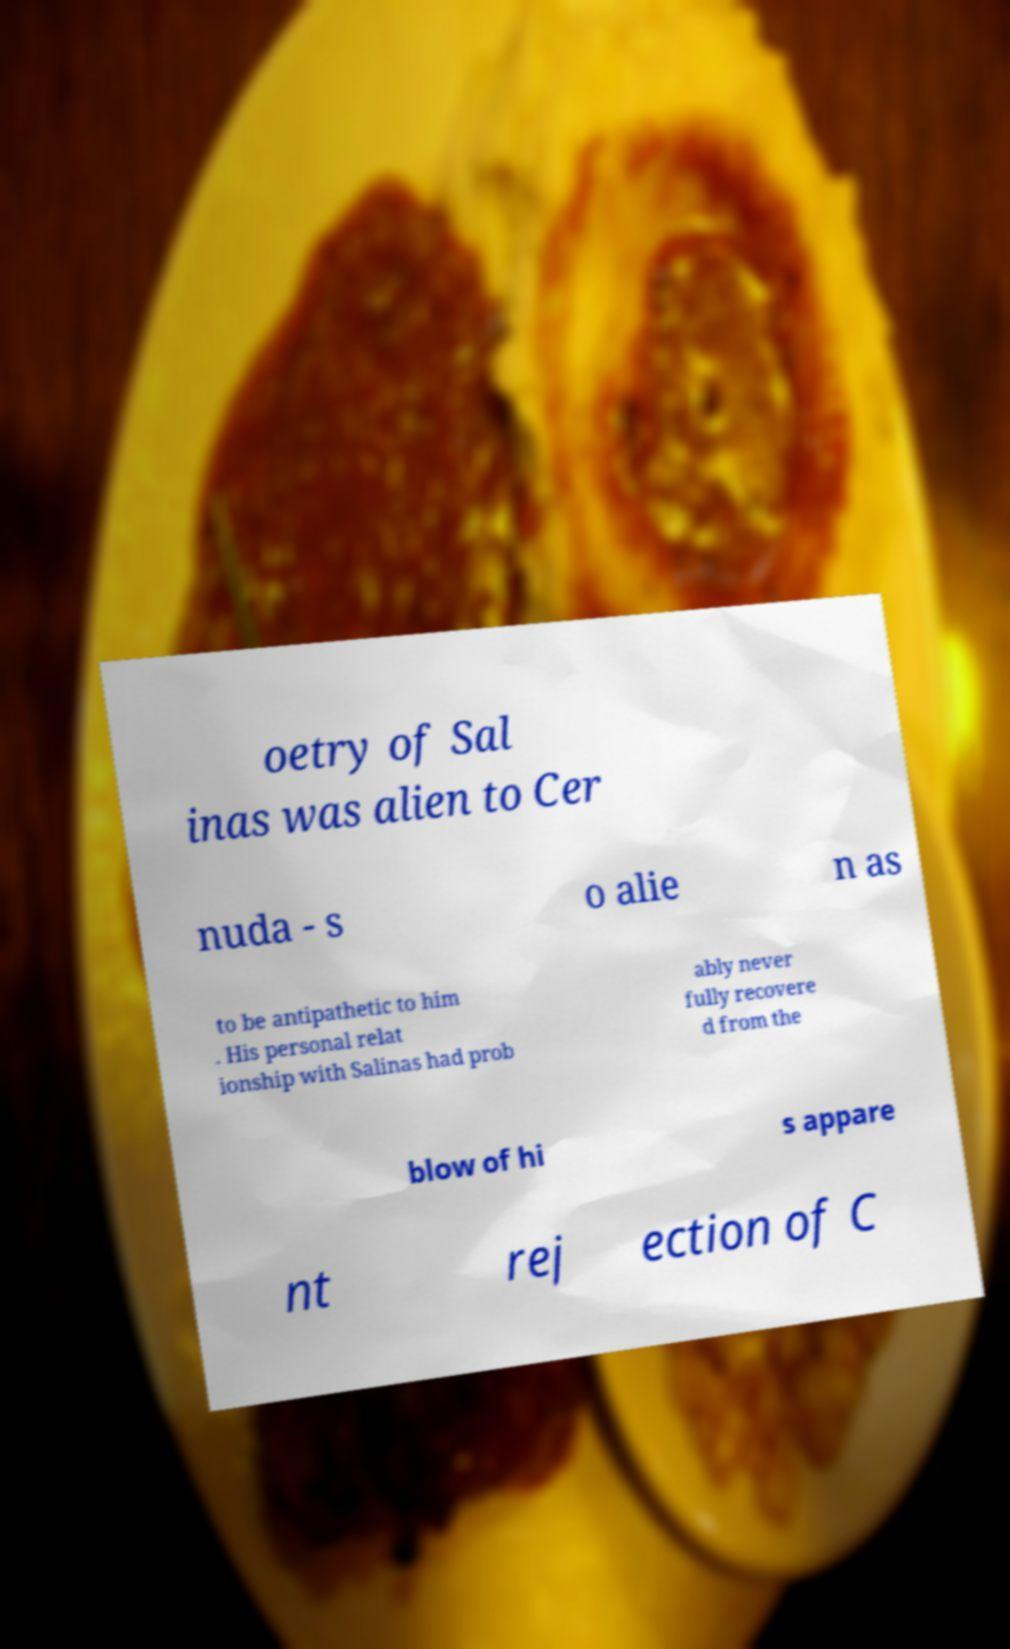Can you accurately transcribe the text from the provided image for me? oetry of Sal inas was alien to Cer nuda - s o alie n as to be antipathetic to him . His personal relat ionship with Salinas had prob ably never fully recovere d from the blow of hi s appare nt rej ection of C 